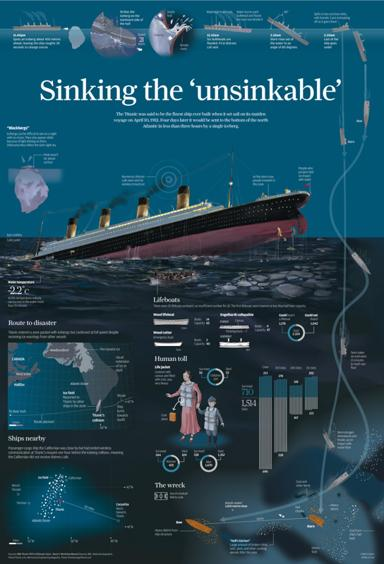What details can you provide about the construction and dimensions of the Titanic as shown in the infographic? The infographic illustrates that the Titanic was approximately 882 feet in length with a breadth of 92 feet. It had a gross tonnage of around 46,328 tons, making it one of the largest passenger liners at the time. 